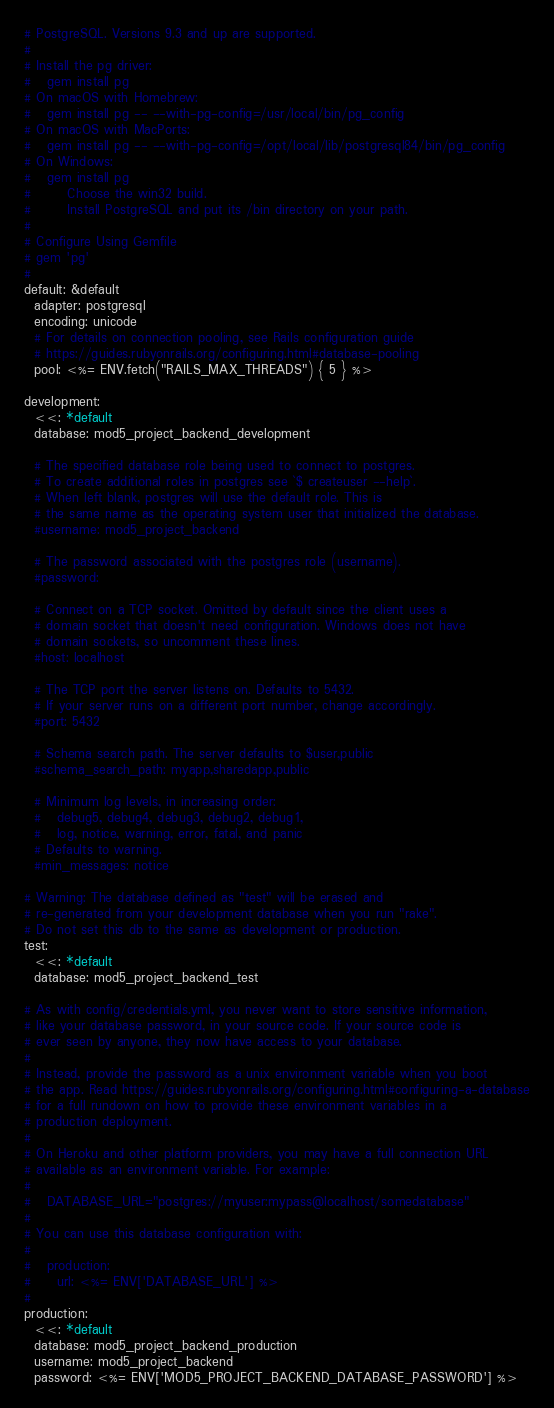<code> <loc_0><loc_0><loc_500><loc_500><_YAML_># PostgreSQL. Versions 9.3 and up are supported.
#
# Install the pg driver:
#   gem install pg
# On macOS with Homebrew:
#   gem install pg -- --with-pg-config=/usr/local/bin/pg_config
# On macOS with MacPorts:
#   gem install pg -- --with-pg-config=/opt/local/lib/postgresql84/bin/pg_config
# On Windows:
#   gem install pg
#       Choose the win32 build.
#       Install PostgreSQL and put its /bin directory on your path.
#
# Configure Using Gemfile
# gem 'pg'
#
default: &default
  adapter: postgresql
  encoding: unicode
  # For details on connection pooling, see Rails configuration guide
  # https://guides.rubyonrails.org/configuring.html#database-pooling
  pool: <%= ENV.fetch("RAILS_MAX_THREADS") { 5 } %>

development:
  <<: *default
  database: mod5_project_backend_development

  # The specified database role being used to connect to postgres.
  # To create additional roles in postgres see `$ createuser --help`.
  # When left blank, postgres will use the default role. This is
  # the same name as the operating system user that initialized the database.
  #username: mod5_project_backend

  # The password associated with the postgres role (username).
  #password:

  # Connect on a TCP socket. Omitted by default since the client uses a
  # domain socket that doesn't need configuration. Windows does not have
  # domain sockets, so uncomment these lines.
  #host: localhost

  # The TCP port the server listens on. Defaults to 5432.
  # If your server runs on a different port number, change accordingly.
  #port: 5432

  # Schema search path. The server defaults to $user,public
  #schema_search_path: myapp,sharedapp,public

  # Minimum log levels, in increasing order:
  #   debug5, debug4, debug3, debug2, debug1,
  #   log, notice, warning, error, fatal, and panic
  # Defaults to warning.
  #min_messages: notice

# Warning: The database defined as "test" will be erased and
# re-generated from your development database when you run "rake".
# Do not set this db to the same as development or production.
test:
  <<: *default
  database: mod5_project_backend_test

# As with config/credentials.yml, you never want to store sensitive information,
# like your database password, in your source code. If your source code is
# ever seen by anyone, they now have access to your database.
#
# Instead, provide the password as a unix environment variable when you boot
# the app. Read https://guides.rubyonrails.org/configuring.html#configuring-a-database
# for a full rundown on how to provide these environment variables in a
# production deployment.
#
# On Heroku and other platform providers, you may have a full connection URL
# available as an environment variable. For example:
#
#   DATABASE_URL="postgres://myuser:mypass@localhost/somedatabase"
#
# You can use this database configuration with:
#
#   production:
#     url: <%= ENV['DATABASE_URL'] %>
#
production:
  <<: *default
  database: mod5_project_backend_production
  username: mod5_project_backend
  password: <%= ENV['MOD5_PROJECT_BACKEND_DATABASE_PASSWORD'] %>
</code> 